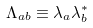<formula> <loc_0><loc_0><loc_500><loc_500>\Lambda _ { a b } \equiv \lambda _ { a } \lambda _ { b } ^ { * }</formula> 